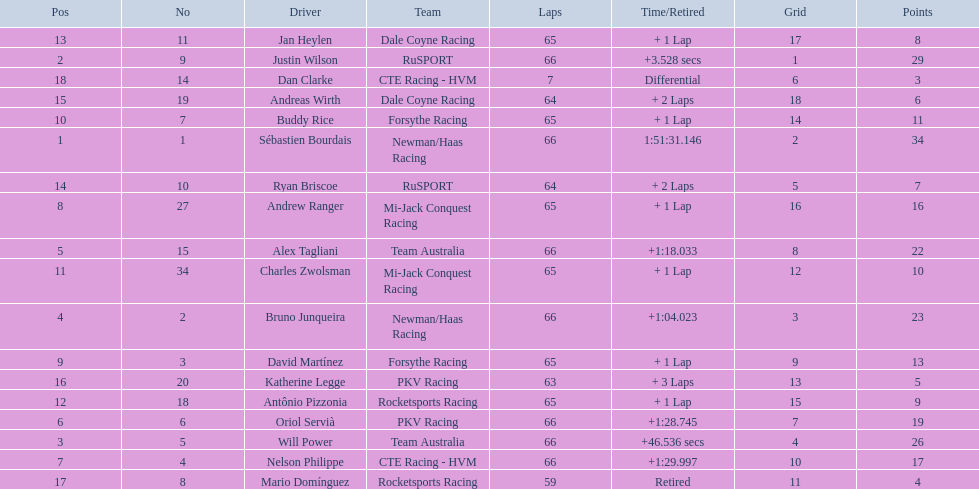How many laps did oriol servia complete at the 2006 gran premio? 66. How many laps did katherine legge complete at the 2006 gran premio? 63. Between servia and legge, who completed more laps? Oriol Servià. 